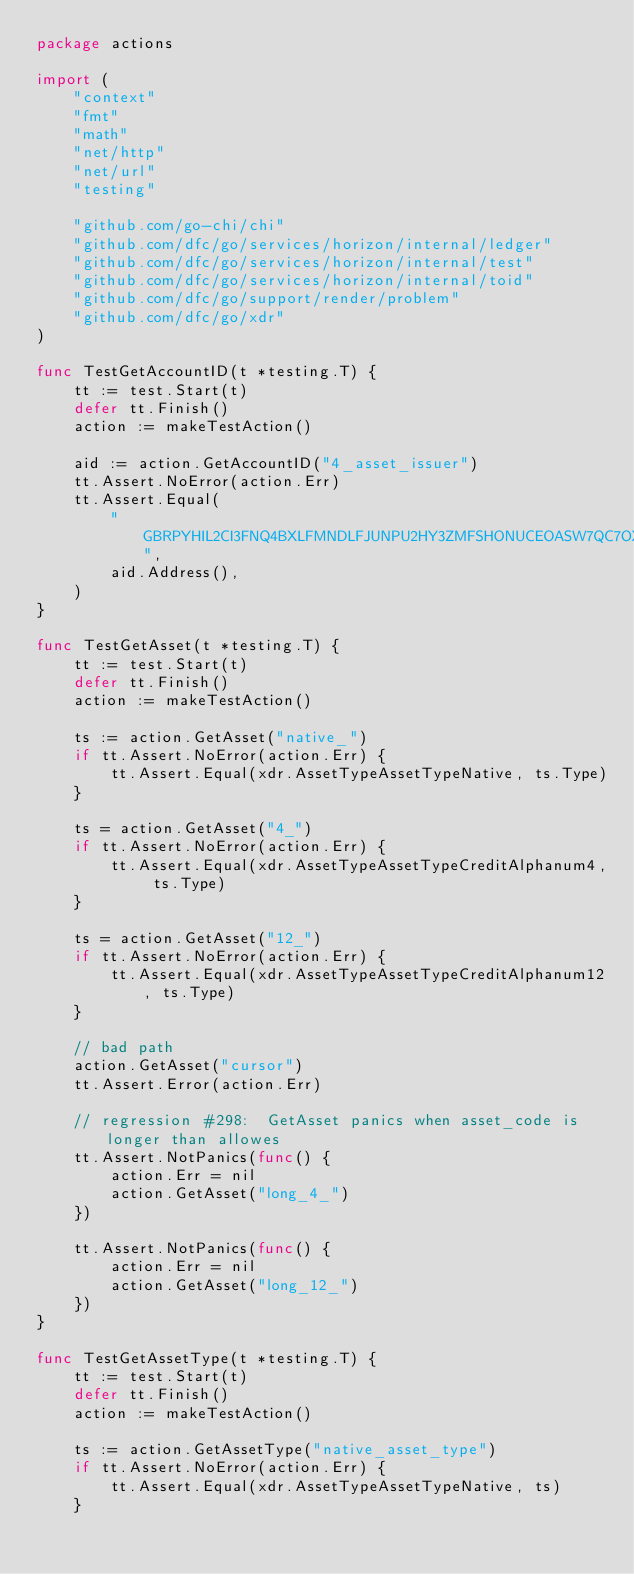Convert code to text. <code><loc_0><loc_0><loc_500><loc_500><_Go_>package actions

import (
	"context"
	"fmt"
	"math"
	"net/http"
	"net/url"
	"testing"

	"github.com/go-chi/chi"
	"github.com/dfc/go/services/horizon/internal/ledger"
	"github.com/dfc/go/services/horizon/internal/test"
	"github.com/dfc/go/services/horizon/internal/toid"
	"github.com/dfc/go/support/render/problem"
	"github.com/dfc/go/xdr"
)

func TestGetAccountID(t *testing.T) {
	tt := test.Start(t)
	defer tt.Finish()
	action := makeTestAction()

	aid := action.GetAccountID("4_asset_issuer")
	tt.Assert.NoError(action.Err)
	tt.Assert.Equal(
		"GBRPYHIL2CI3FNQ4BXLFMNDLFJUNPU2HY3ZMFSHONUCEOASW7QC7OX2H",
		aid.Address(),
	)
}

func TestGetAsset(t *testing.T) {
	tt := test.Start(t)
	defer tt.Finish()
	action := makeTestAction()

	ts := action.GetAsset("native_")
	if tt.Assert.NoError(action.Err) {
		tt.Assert.Equal(xdr.AssetTypeAssetTypeNative, ts.Type)
	}

	ts = action.GetAsset("4_")
	if tt.Assert.NoError(action.Err) {
		tt.Assert.Equal(xdr.AssetTypeAssetTypeCreditAlphanum4, ts.Type)
	}

	ts = action.GetAsset("12_")
	if tt.Assert.NoError(action.Err) {
		tt.Assert.Equal(xdr.AssetTypeAssetTypeCreditAlphanum12, ts.Type)
	}

	// bad path
	action.GetAsset("cursor")
	tt.Assert.Error(action.Err)

	// regression #298:  GetAsset panics when asset_code is longer than allowes
	tt.Assert.NotPanics(func() {
		action.Err = nil
		action.GetAsset("long_4_")
	})

	tt.Assert.NotPanics(func() {
		action.Err = nil
		action.GetAsset("long_12_")
	})
}

func TestGetAssetType(t *testing.T) {
	tt := test.Start(t)
	defer tt.Finish()
	action := makeTestAction()

	ts := action.GetAssetType("native_asset_type")
	if tt.Assert.NoError(action.Err) {
		tt.Assert.Equal(xdr.AssetTypeAssetTypeNative, ts)
	}
</code> 